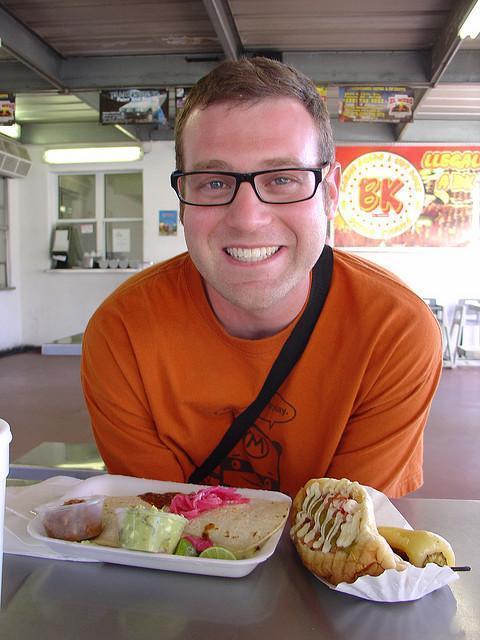Is the statement "The person is touching the hot dog." accurate regarding the image?
Answer yes or no. No. 